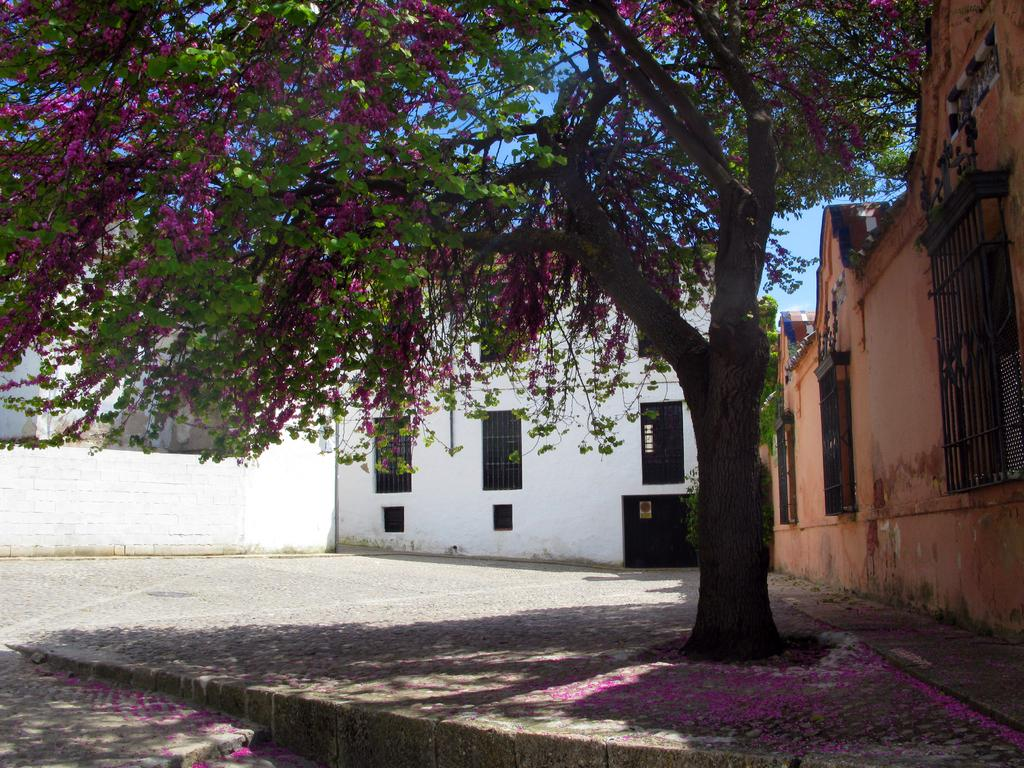What type of plant can be seen in the image? There is a tree in the image. What is special about the tree in the image? The tree has flowers on it. What else can be seen in the image besides the tree? There are buildings visible in the image. What is visible at the top of the image? The sky is visible at the top of the image. How many facts are being rubbed off the shoes in the image? There are no shoes or facts being rubbed off in the image. 